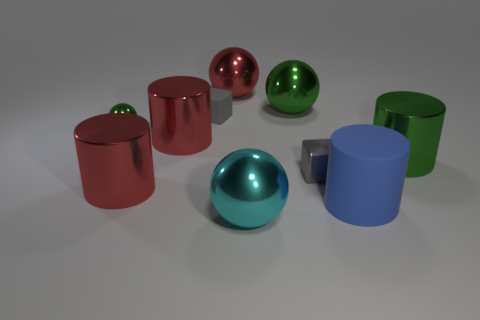Subtract all gray cubes. How many were subtracted if there are1gray cubes left? 1 Subtract 2 spheres. How many spheres are left? 2 Subtract all blue cylinders. How many cylinders are left? 3 Subtract all matte cylinders. How many cylinders are left? 3 Subtract all red blocks. Subtract all purple spheres. How many blocks are left? 2 Subtract all spheres. How many objects are left? 6 Add 8 cyan spheres. How many cyan spheres are left? 9 Add 6 cyan objects. How many cyan objects exist? 7 Subtract 0 gray spheres. How many objects are left? 10 Subtract all cubes. Subtract all cyan metallic balls. How many objects are left? 7 